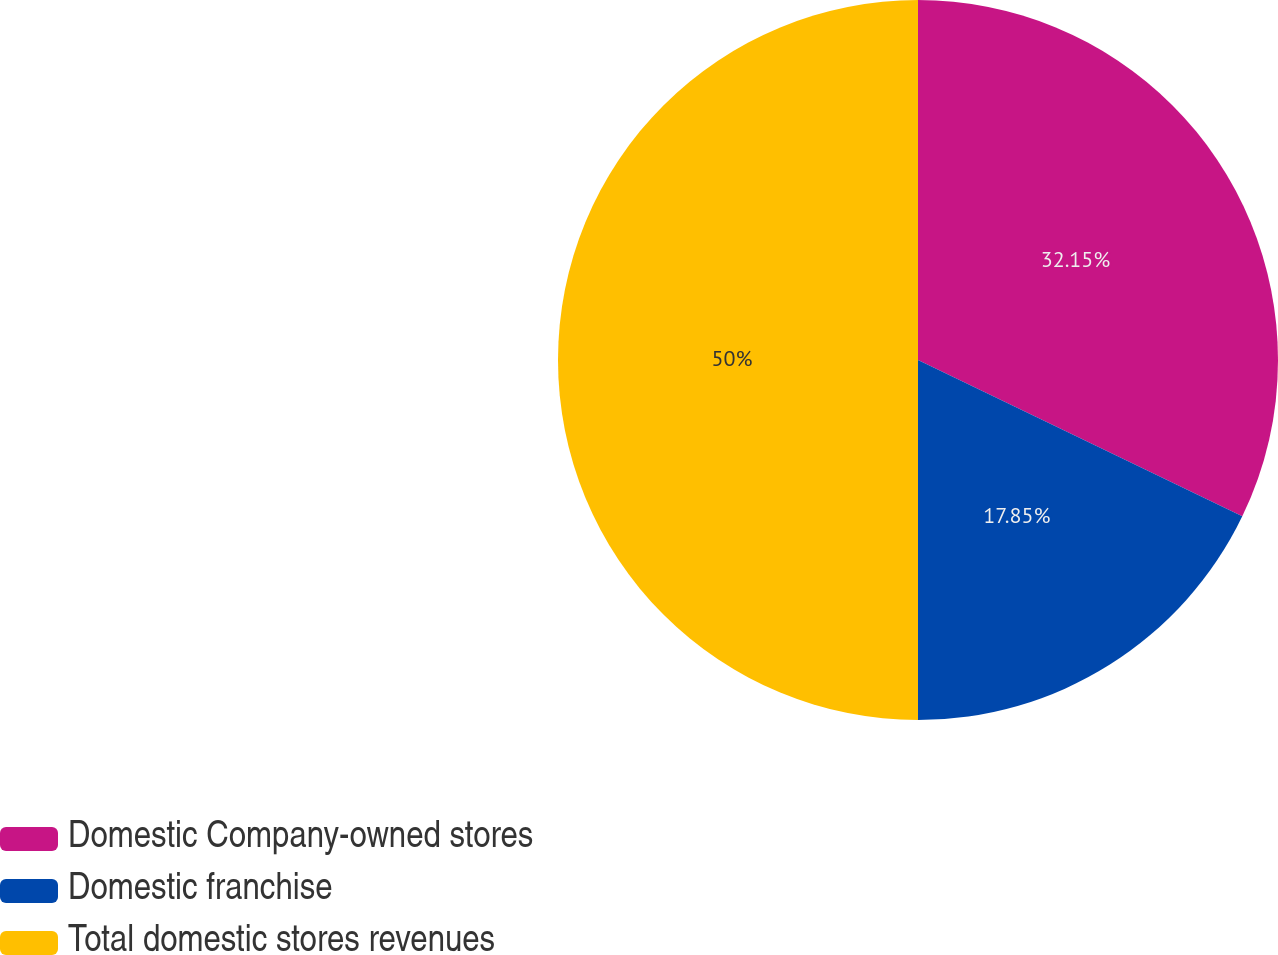Convert chart. <chart><loc_0><loc_0><loc_500><loc_500><pie_chart><fcel>Domestic Company-owned stores<fcel>Domestic franchise<fcel>Total domestic stores revenues<nl><fcel>32.15%<fcel>17.85%<fcel>50.0%<nl></chart> 